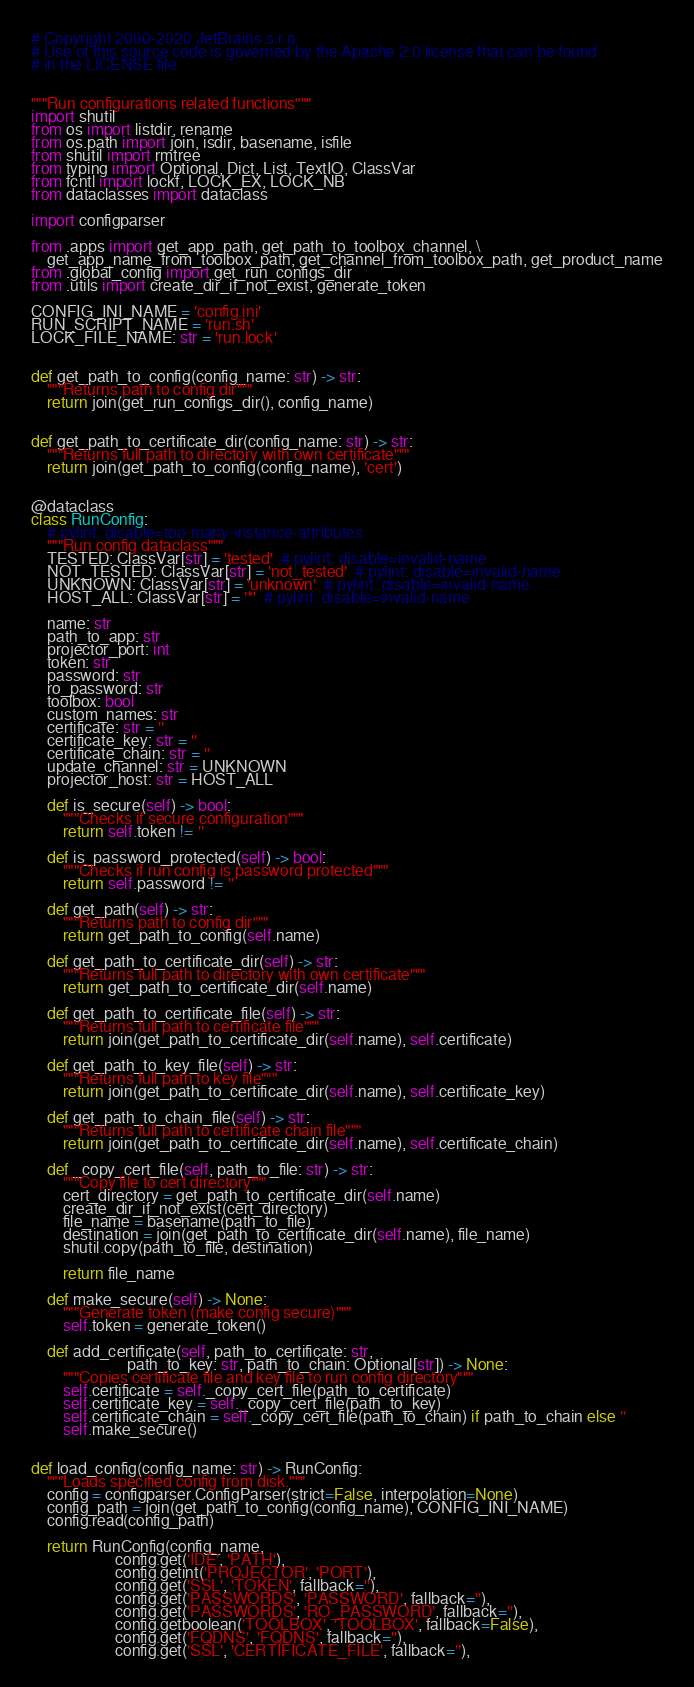Convert code to text. <code><loc_0><loc_0><loc_500><loc_500><_Python_># Copyright 2000-2020 JetBrains s.r.o.
# Use of this source code is governed by the Apache 2.0 license that can be found
# in the LICENSE file.


"""Run configurations related functions"""
import shutil
from os import listdir, rename
from os.path import join, isdir, basename, isfile
from shutil import rmtree
from typing import Optional, Dict, List, TextIO, ClassVar
from fcntl import lockf, LOCK_EX, LOCK_NB
from dataclasses import dataclass

import configparser

from .apps import get_app_path, get_path_to_toolbox_channel, \
    get_app_name_from_toolbox_path, get_channel_from_toolbox_path, get_product_name
from .global_config import get_run_configs_dir
from .utils import create_dir_if_not_exist, generate_token

CONFIG_INI_NAME = 'config.ini'
RUN_SCRIPT_NAME = 'run.sh'
LOCK_FILE_NAME: str = 'run.lock'


def get_path_to_config(config_name: str) -> str:
    """Returns path to config dir"""
    return join(get_run_configs_dir(), config_name)


def get_path_to_certificate_dir(config_name: str) -> str:
    """Returns full path to directory with own certificate"""
    return join(get_path_to_config(config_name), 'cert')


@dataclass
class RunConfig:
    # pylint: disable=too-many-instance-attributes
    """Run config dataclass"""
    TESTED: ClassVar[str] = 'tested'  # pylint: disable=invalid-name
    NOT_TESTED: ClassVar[str] = 'not_tested'  # pylint: disable=invalid-name
    UNKNOWN: ClassVar[str] = 'unknown'  # pylint: disable=invalid-name
    HOST_ALL: ClassVar[str] = '*'  # pylint: disable=invalid-name

    name: str
    path_to_app: str
    projector_port: int
    token: str
    password: str
    ro_password: str
    toolbox: bool
    custom_names: str
    certificate: str = ''
    certificate_key: str = ''
    certificate_chain: str = ''
    update_channel: str = UNKNOWN
    projector_host: str = HOST_ALL

    def is_secure(self) -> bool:
        """Checks if secure configuration"""
        return self.token != ''

    def is_password_protected(self) -> bool:
        """Checks if run config is password protected"""
        return self.password != ''

    def get_path(self) -> str:
        """Returns path to config dir"""
        return get_path_to_config(self.name)

    def get_path_to_certificate_dir(self) -> str:
        """Returns full path to directory with own certificate"""
        return get_path_to_certificate_dir(self.name)

    def get_path_to_certificate_file(self) -> str:
        """Returns full path to certificate file"""
        return join(get_path_to_certificate_dir(self.name), self.certificate)

    def get_path_to_key_file(self) -> str:
        """Returns full path to key file"""
        return join(get_path_to_certificate_dir(self.name), self.certificate_key)

    def get_path_to_chain_file(self) -> str:
        """Returns full path to certificate chain file"""
        return join(get_path_to_certificate_dir(self.name), self.certificate_chain)

    def _copy_cert_file(self, path_to_file: str) -> str:
        """Copy file to cert directory"""
        cert_directory = get_path_to_certificate_dir(self.name)
        create_dir_if_not_exist(cert_directory)
        file_name = basename(path_to_file)
        destination = join(get_path_to_certificate_dir(self.name), file_name)
        shutil.copy(path_to_file, destination)

        return file_name

    def make_secure(self) -> None:
        """Generate token (make config secure)"""
        self.token = generate_token()

    def add_certificate(self, path_to_certificate: str,
                        path_to_key: str, path_to_chain: Optional[str]) -> None:
        """Copies certificate file and key file to run config directory"""
        self.certificate = self._copy_cert_file(path_to_certificate)
        self.certificate_key = self._copy_cert_file(path_to_key)
        self.certificate_chain = self._copy_cert_file(path_to_chain) if path_to_chain else ''
        self.make_secure()


def load_config(config_name: str) -> RunConfig:
    """Loads specified config from disk."""
    config = configparser.ConfigParser(strict=False, interpolation=None)
    config_path = join(get_path_to_config(config_name), CONFIG_INI_NAME)
    config.read(config_path)

    return RunConfig(config_name,
                     config.get('IDE', 'PATH'),
                     config.getint('PROJECTOR', 'PORT'),
                     config.get('SSL', 'TOKEN', fallback=''),
                     config.get('PASSWORDS', 'PASSWORD', fallback=''),
                     config.get('PASSWORDS', 'RO_PASSWORD', fallback=''),
                     config.getboolean('TOOLBOX', 'TOOLBOX', fallback=False),
                     config.get('FQDNS', 'FQDNS', fallback=''),
                     config.get('SSL', 'CERTIFICATE_FILE', fallback=''),</code> 